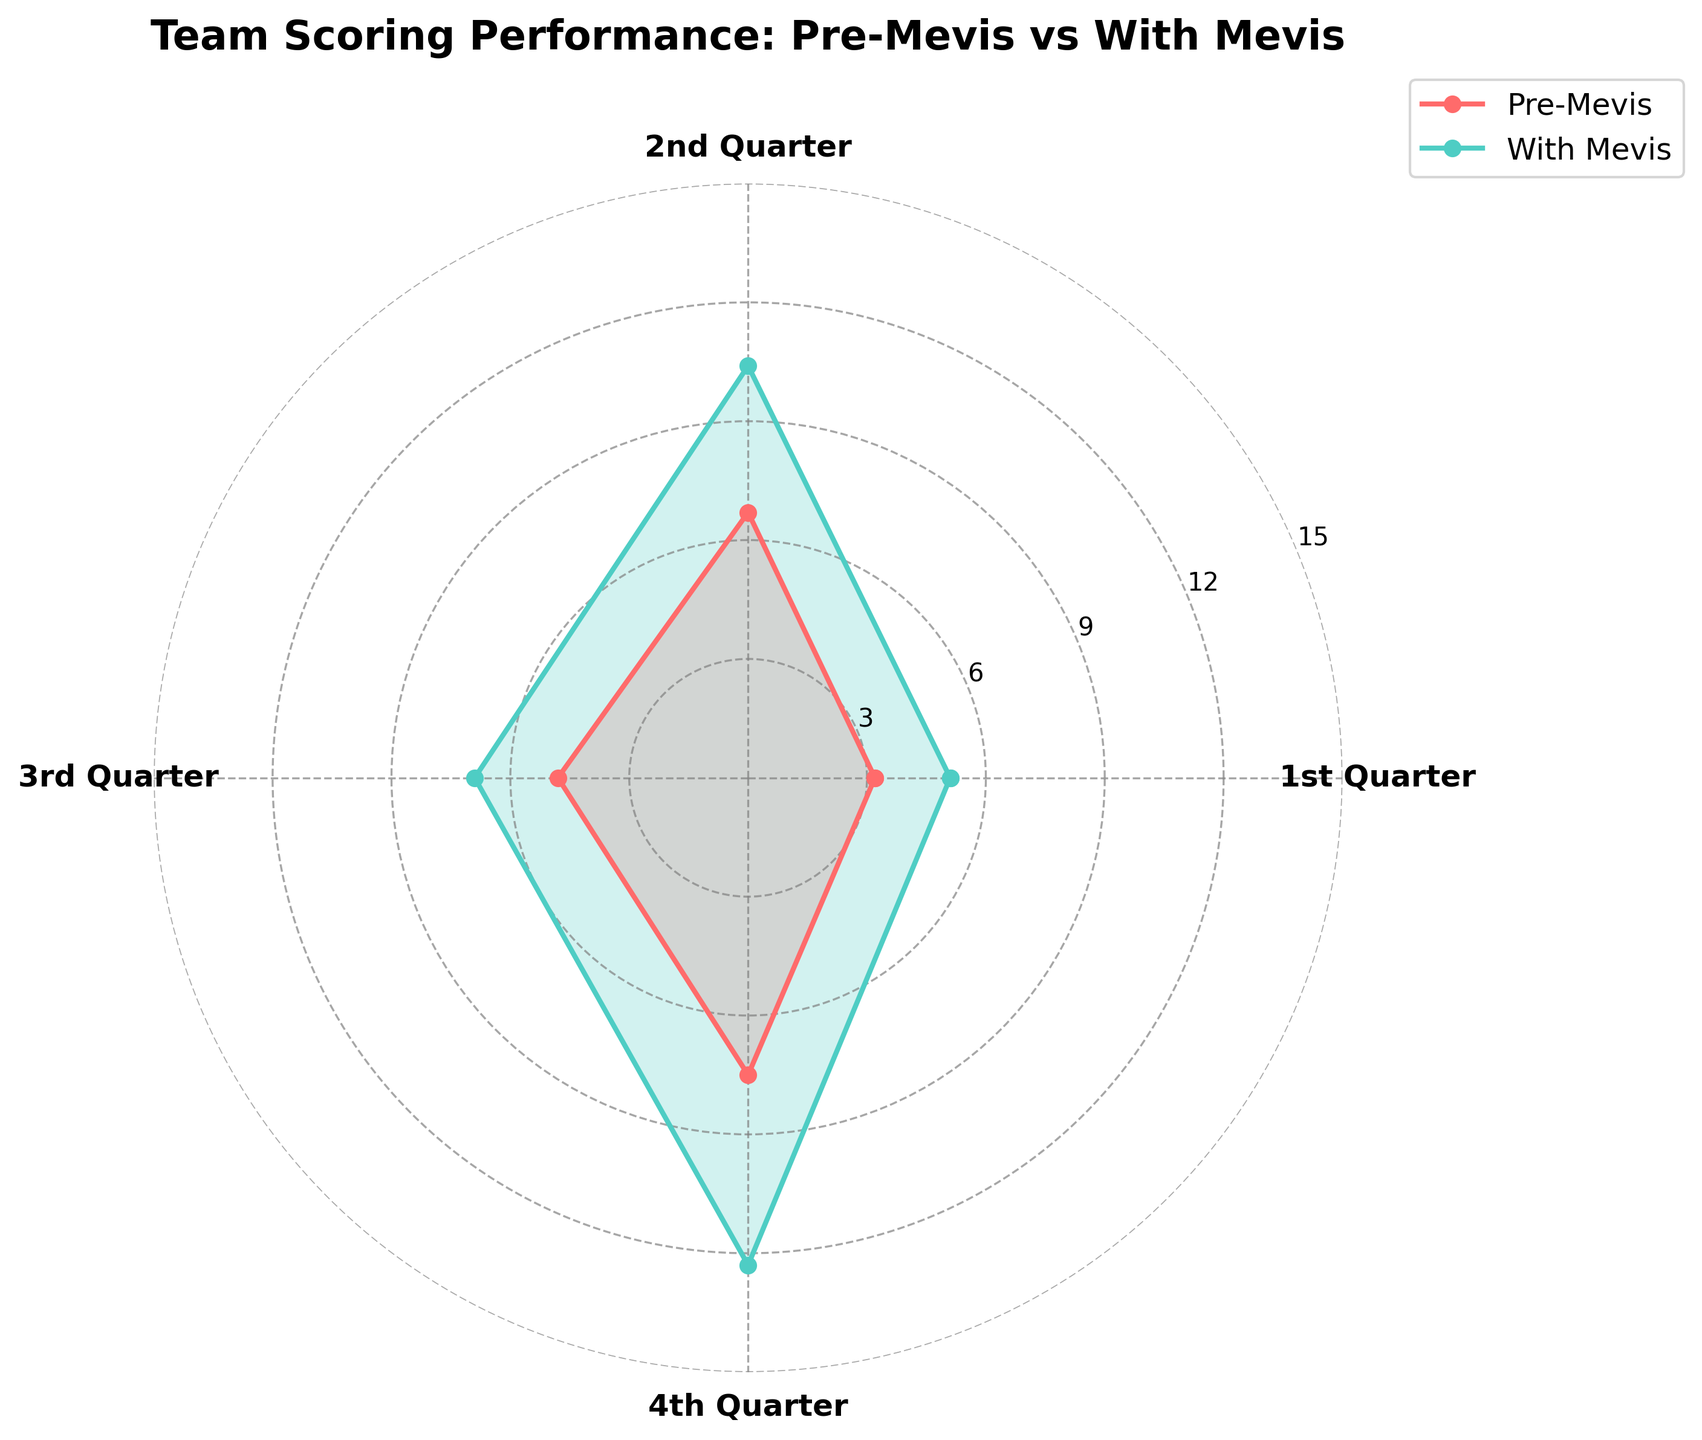What is the title of the radar chart? The title of the radar chart is displayed at the top and reads "Team Scoring Performance: Pre-Mevis vs With Mevis".
Answer: Team Scoring Performance: Pre-Mevis vs With Mevis How many categories are compared in the radar chart? The radar chart shows four categories: 1st Quarter, 2nd Quarter, 3rd Quarter, and 4th Quarter. We can count these based on the labels around the chart.
Answer: Four Which quarter has the highest average points with Mevis? By checking the 'With Mevis Avg Points' data around the radar chart, the 4th Quarter has the highest value of 12.3 points.
Answer: 4th Quarter How much did the average points increase in the 1st Quarter after Andrew Mevis joined the team? Subtract the Pre-Mevis Avg Points for the 1st Quarter from the With Mevis Avg Points: 5.1 - 3.2.
Answer: 1.9 points Compare the team's scoring performance in the 3rd Quarter pre- and post-Mevis. Which one is higher and by how much? The average points in the 3rd Quarter are 4.8 pre-Mevis and 6.9 with Mevis. So, 6.9 is greater by 2.1 points.
Answer: With Mevis by 2.1 points On average, in which quarter did the team experience the smallest increase in points with Mevis compared to pre-Mevis? Calculate the difference for each quarter and find the smallest: 1st (1.9), 2nd (3.7), 3rd (2.1), 4th (4.8). The smallest increase is in the 1st Quarter with 1.9 points.
Answer: 1st Quarter What color is used to represent the Pre-Mevis data? The color used for the Pre-Mevis data line and the highlighted area is red.
Answer: Red What's the average points of all quarters Pre-Mevis? Sum up Pre-Mevis points: 3.2 + 6.7 + 4.8 + 7.5 = 22.2, then divide by the number of quarters, 22.2 / 4.
Answer: 5.55 points By how many points did the team's average points in the 2nd Quarter improve with Mevis compared to the 1st Quarter? Compare the With Mevis Avg points in the 2nd Quarter and the 1st Quarter: 10.4 - 5.1.
Answer: 5.3 points Does the team score more consistently across quarters with Mevis or Pre-Mevis? Consistency can be interpreted as having similar scores across quarters. The range of points for Pre-Mevis is (7.5 - 3.2 = 4.3), and for With Mevis is (12.3 - 5.1 = 7.2). The smaller range indicates more consistency, so the team scores more consistently Pre-Mevis.
Answer: Pre-Mevis 